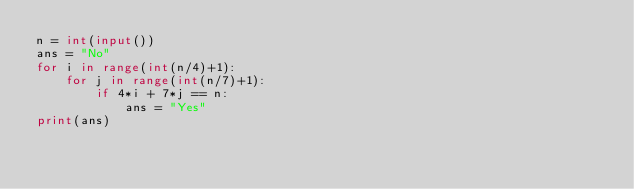<code> <loc_0><loc_0><loc_500><loc_500><_Python_>n = int(input())
ans = "No"
for i in range(int(n/4)+1):
    for j in range(int(n/7)+1):
        if 4*i + 7*j == n:
            ans = "Yes"
print(ans)</code> 